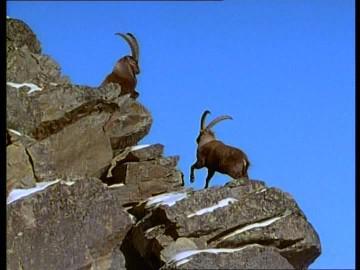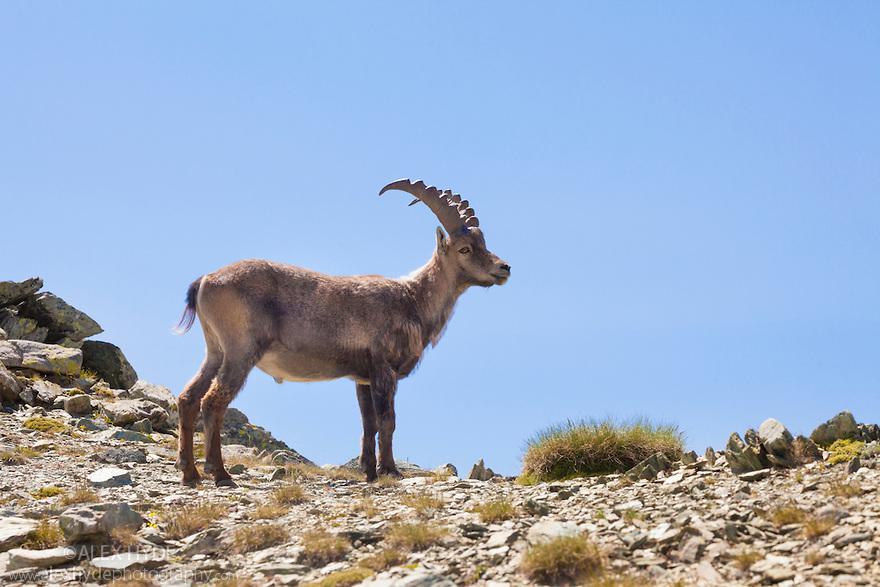The first image is the image on the left, the second image is the image on the right. Considering the images on both sides, is "There are 2 goats on the mountain." valid? Answer yes or no. No. The first image is the image on the left, the second image is the image on the right. For the images displayed, is the sentence "In one image, two animals with large upright horns are perched on a high rocky area." factually correct? Answer yes or no. Yes. 